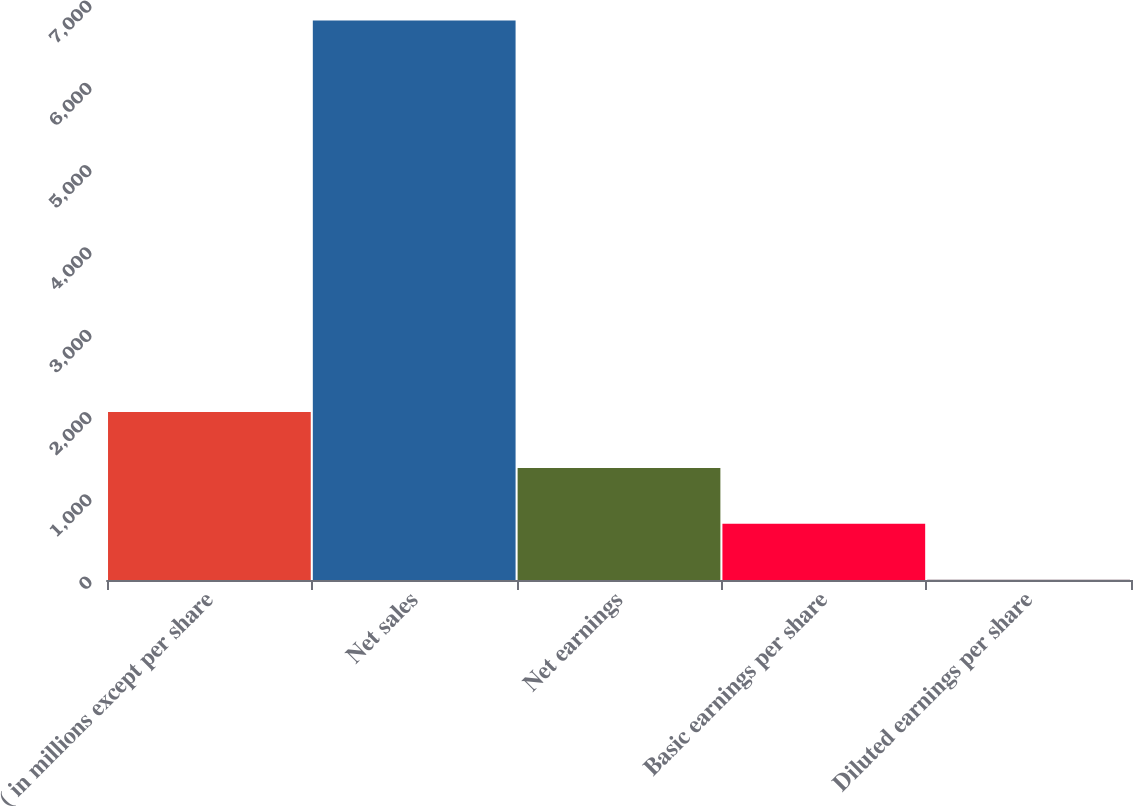<chart> <loc_0><loc_0><loc_500><loc_500><bar_chart><fcel>( in millions except per share<fcel>Net sales<fcel>Net earnings<fcel>Basic earnings per share<fcel>Diluted earnings per share<nl><fcel>2041.91<fcel>6799<fcel>1362.33<fcel>682.74<fcel>3.15<nl></chart> 